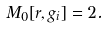<formula> <loc_0><loc_0><loc_500><loc_500>M _ { 0 } [ r , g _ { i } ] = 2 .</formula> 